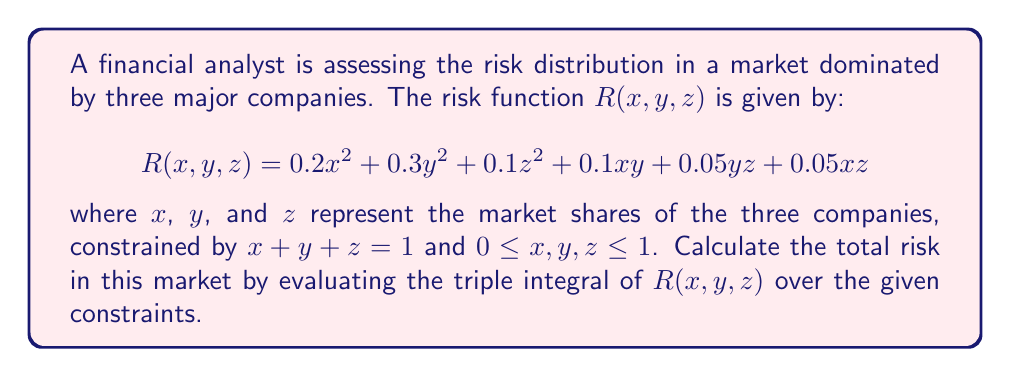Could you help me with this problem? To solve this problem, we need to set up and evaluate a triple integral over the given domain. The domain is a triangular region in the xy-plane, with z determined by the constraint $x + y + z = 1$.

1) First, we need to express z in terms of x and y:
   $z = 1 - x - y$

2) The limits of integration for x and y form a triangle in the xy-plane:
   $0 \leq x \leq 1$
   $0 \leq y \leq 1-x$

3) We can now set up the triple integral:

   $$\iiint_V R(x,y,z) dV = \int_0^1 \int_0^{1-x} \int_0^{1-x-y} R(x,y,z) dz dy dx$$

4) Substituting the expression for z and simplifying:

   $$\int_0^1 \int_0^{1-x} [0.2x^2 + 0.3y^2 + 0.1(1-x-y)^2 + 0.1xy + 0.05y(1-x-y) + 0.05x(1-x-y)] dy dx$$

5) Expanding the integrand:

   $$\int_0^1 \int_0^{1-x} [0.2x^2 + 0.3y^2 + 0.1(1-2x-2y+x^2+2xy+y^2) + 0.1xy + 0.05y-0.05xy-0.05y^2 + 0.05x-0.05x^2-0.05xy] dy dx$$

6) Simplifying:

   $$\int_0^1 \int_0^{1-x} [0.25x^2 + 0.35y^2 + 0.1 - 0.2x - 0.2y + 0.1xy + 0.05y + 0.05x] dy dx$$

7) Integrating with respect to y:

   $$\int_0^1 [0.25x^2(1-x) + 0.35\frac{(1-x)^3}{3} + 0.1(1-x) - 0.2x(1-x) - 0.2\frac{(1-x)^2}{2} + 0.1x\frac{(1-x)^2}{2} + 0.05\frac{(1-x)^2}{2} + 0.05x(1-x)] dx$$

8) Integrating with respect to x:

   $$[0.25(\frac{x^3}{3}-\frac{x^4}{4}) + 0.35(\frac{1}{3}-x+\frac{x^2}{2}-\frac{x^3}{6}) + 0.1(x-\frac{x^2}{2}) - 0.2(\frac{x^2}{2}-\frac{x^3}{3}) - 0.2(\frac{x}{2}-\frac{x^2}{2}+\frac{x^3}{6}) + 0.1(\frac{x^3}{6}-\frac{x^4}{8}) + 0.05(\frac{x}{2}-\frac{x^2}{2}+\frac{x^3}{6}) + 0.05(\frac{x^2}{2}-\frac{x^3}{3})]_0^1$$

9) Evaluating at the limits and simplifying:

   $$0.0833 + 0.1167 + 0.05 - 0.0333 - 0.0333 + 0.0208 + 0.0167 + 0.0167 = 0.2376$$
Answer: The total risk in the market, calculated by evaluating the triple integral of the risk function over the given constraints, is approximately 0.2376. 